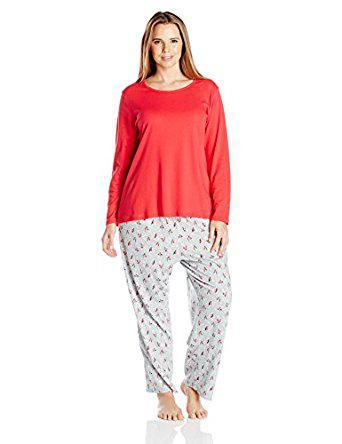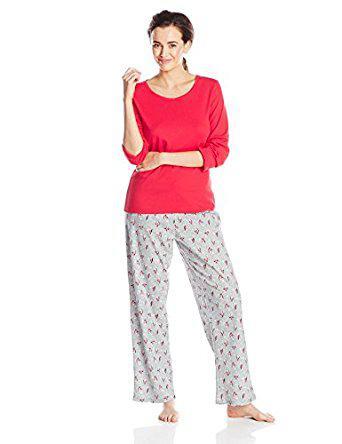The first image is the image on the left, the second image is the image on the right. For the images shown, is this caption "There is a person with one arm raised so that that hand is approximately level with their shoulder." true? Answer yes or no. Yes. The first image is the image on the left, the second image is the image on the right. Analyze the images presented: Is the assertion "There is a woman leaning on her right leg in the left image." valid? Answer yes or no. Yes. 